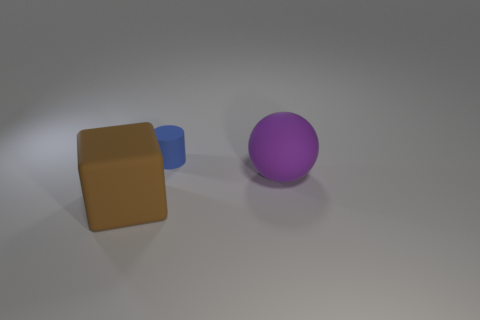Do the objects appear to be in motion or stationary? The objects in the image appear to be stationary. There are no signs of motion blur or other indications that would suggest movement. 